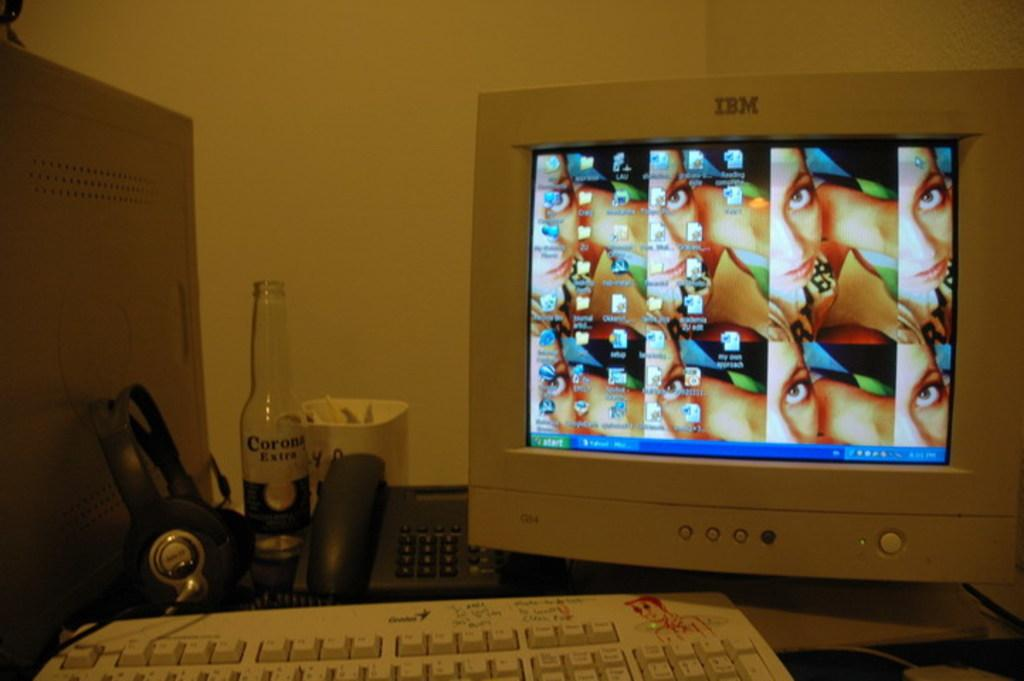<image>
Offer a succinct explanation of the picture presented. A bottle of Corona in front of a keyboard. 